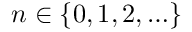Convert formula to latex. <formula><loc_0><loc_0><loc_500><loc_500>n \in \{ 0 , 1 , 2 , \dots \}</formula> 